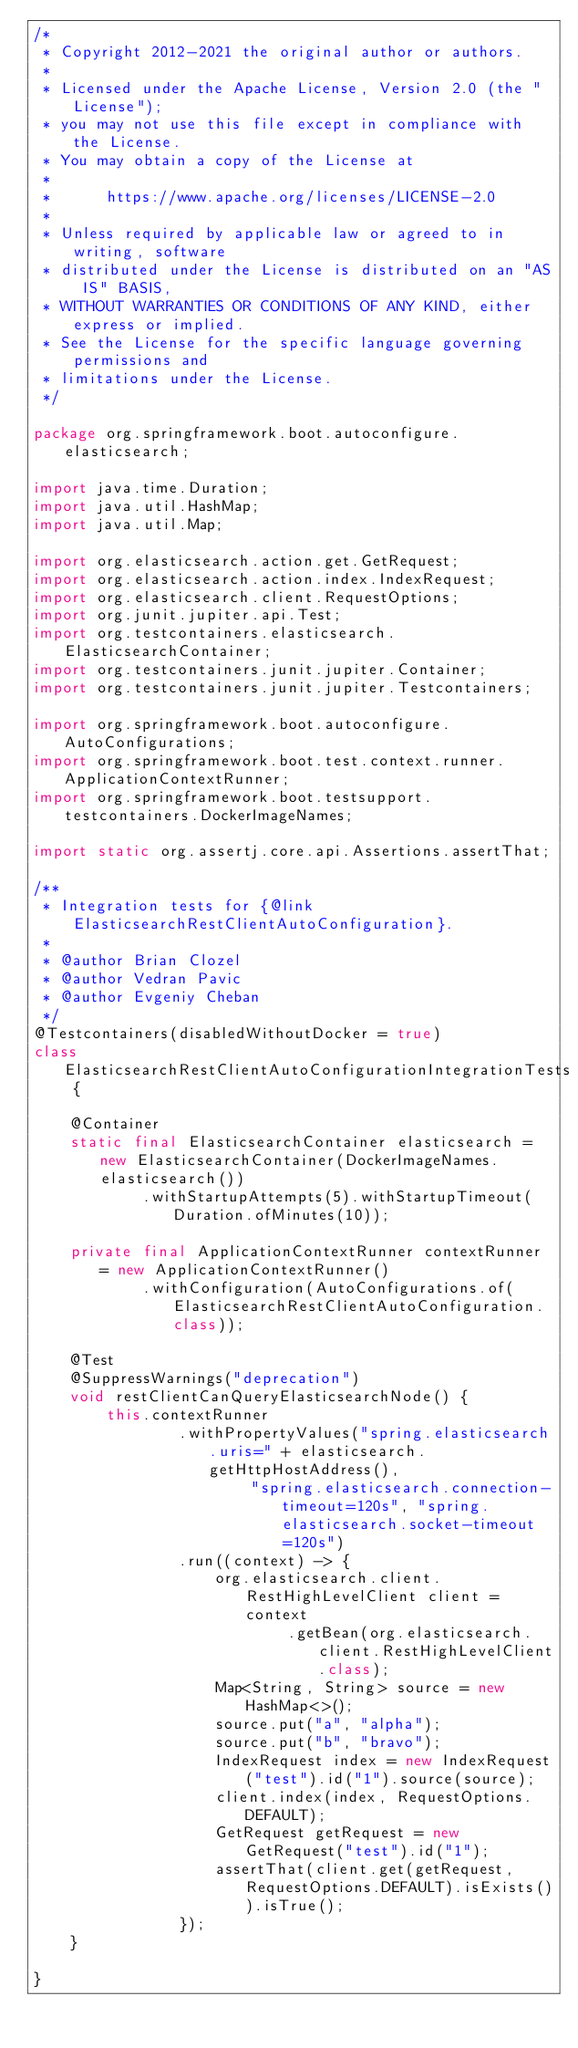<code> <loc_0><loc_0><loc_500><loc_500><_Java_>/*
 * Copyright 2012-2021 the original author or authors.
 *
 * Licensed under the Apache License, Version 2.0 (the "License");
 * you may not use this file except in compliance with the License.
 * You may obtain a copy of the License at
 *
 *      https://www.apache.org/licenses/LICENSE-2.0
 *
 * Unless required by applicable law or agreed to in writing, software
 * distributed under the License is distributed on an "AS IS" BASIS,
 * WITHOUT WARRANTIES OR CONDITIONS OF ANY KIND, either express or implied.
 * See the License for the specific language governing permissions and
 * limitations under the License.
 */

package org.springframework.boot.autoconfigure.elasticsearch;

import java.time.Duration;
import java.util.HashMap;
import java.util.Map;

import org.elasticsearch.action.get.GetRequest;
import org.elasticsearch.action.index.IndexRequest;
import org.elasticsearch.client.RequestOptions;
import org.junit.jupiter.api.Test;
import org.testcontainers.elasticsearch.ElasticsearchContainer;
import org.testcontainers.junit.jupiter.Container;
import org.testcontainers.junit.jupiter.Testcontainers;

import org.springframework.boot.autoconfigure.AutoConfigurations;
import org.springframework.boot.test.context.runner.ApplicationContextRunner;
import org.springframework.boot.testsupport.testcontainers.DockerImageNames;

import static org.assertj.core.api.Assertions.assertThat;

/**
 * Integration tests for {@link ElasticsearchRestClientAutoConfiguration}.
 *
 * @author Brian Clozel
 * @author Vedran Pavic
 * @author Evgeniy Cheban
 */
@Testcontainers(disabledWithoutDocker = true)
class ElasticsearchRestClientAutoConfigurationIntegrationTests {

	@Container
	static final ElasticsearchContainer elasticsearch = new ElasticsearchContainer(DockerImageNames.elasticsearch())
			.withStartupAttempts(5).withStartupTimeout(Duration.ofMinutes(10));

	private final ApplicationContextRunner contextRunner = new ApplicationContextRunner()
			.withConfiguration(AutoConfigurations.of(ElasticsearchRestClientAutoConfiguration.class));

	@Test
	@SuppressWarnings("deprecation")
	void restClientCanQueryElasticsearchNode() {
		this.contextRunner
				.withPropertyValues("spring.elasticsearch.uris=" + elasticsearch.getHttpHostAddress(),
						"spring.elasticsearch.connection-timeout=120s", "spring.elasticsearch.socket-timeout=120s")
				.run((context) -> {
					org.elasticsearch.client.RestHighLevelClient client = context
							.getBean(org.elasticsearch.client.RestHighLevelClient.class);
					Map<String, String> source = new HashMap<>();
					source.put("a", "alpha");
					source.put("b", "bravo");
					IndexRequest index = new IndexRequest("test").id("1").source(source);
					client.index(index, RequestOptions.DEFAULT);
					GetRequest getRequest = new GetRequest("test").id("1");
					assertThat(client.get(getRequest, RequestOptions.DEFAULT).isExists()).isTrue();
				});
	}

}
</code> 